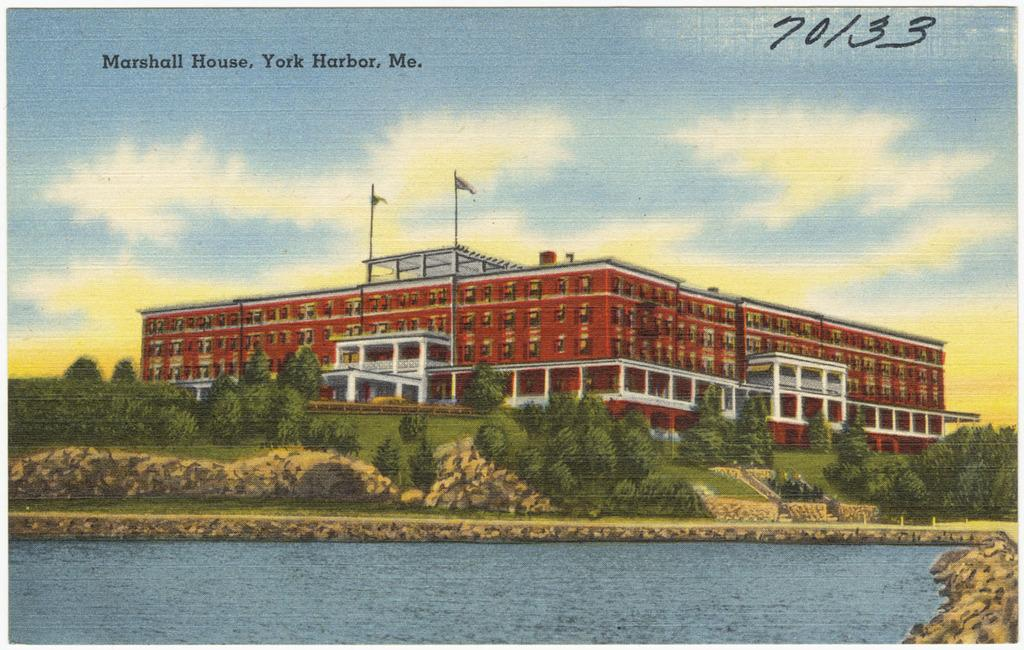What is featured on the poster in the image? The poster contains a building. What specific details can be observed about the building on the poster? The building has windows. What natural elements are visible in the image? There is water, trees, and grass in the image. What man-made structures are present in the image? There are poles in the image. How would you describe the weather in the image? The sky is cloudy in the image. What type of glove is being used by the duck in the image? There is no duck or glove present in the image. What event is taking place in the image? The image does not depict any specific event; it shows a poster with a building, water, trees, grass, and poles. 